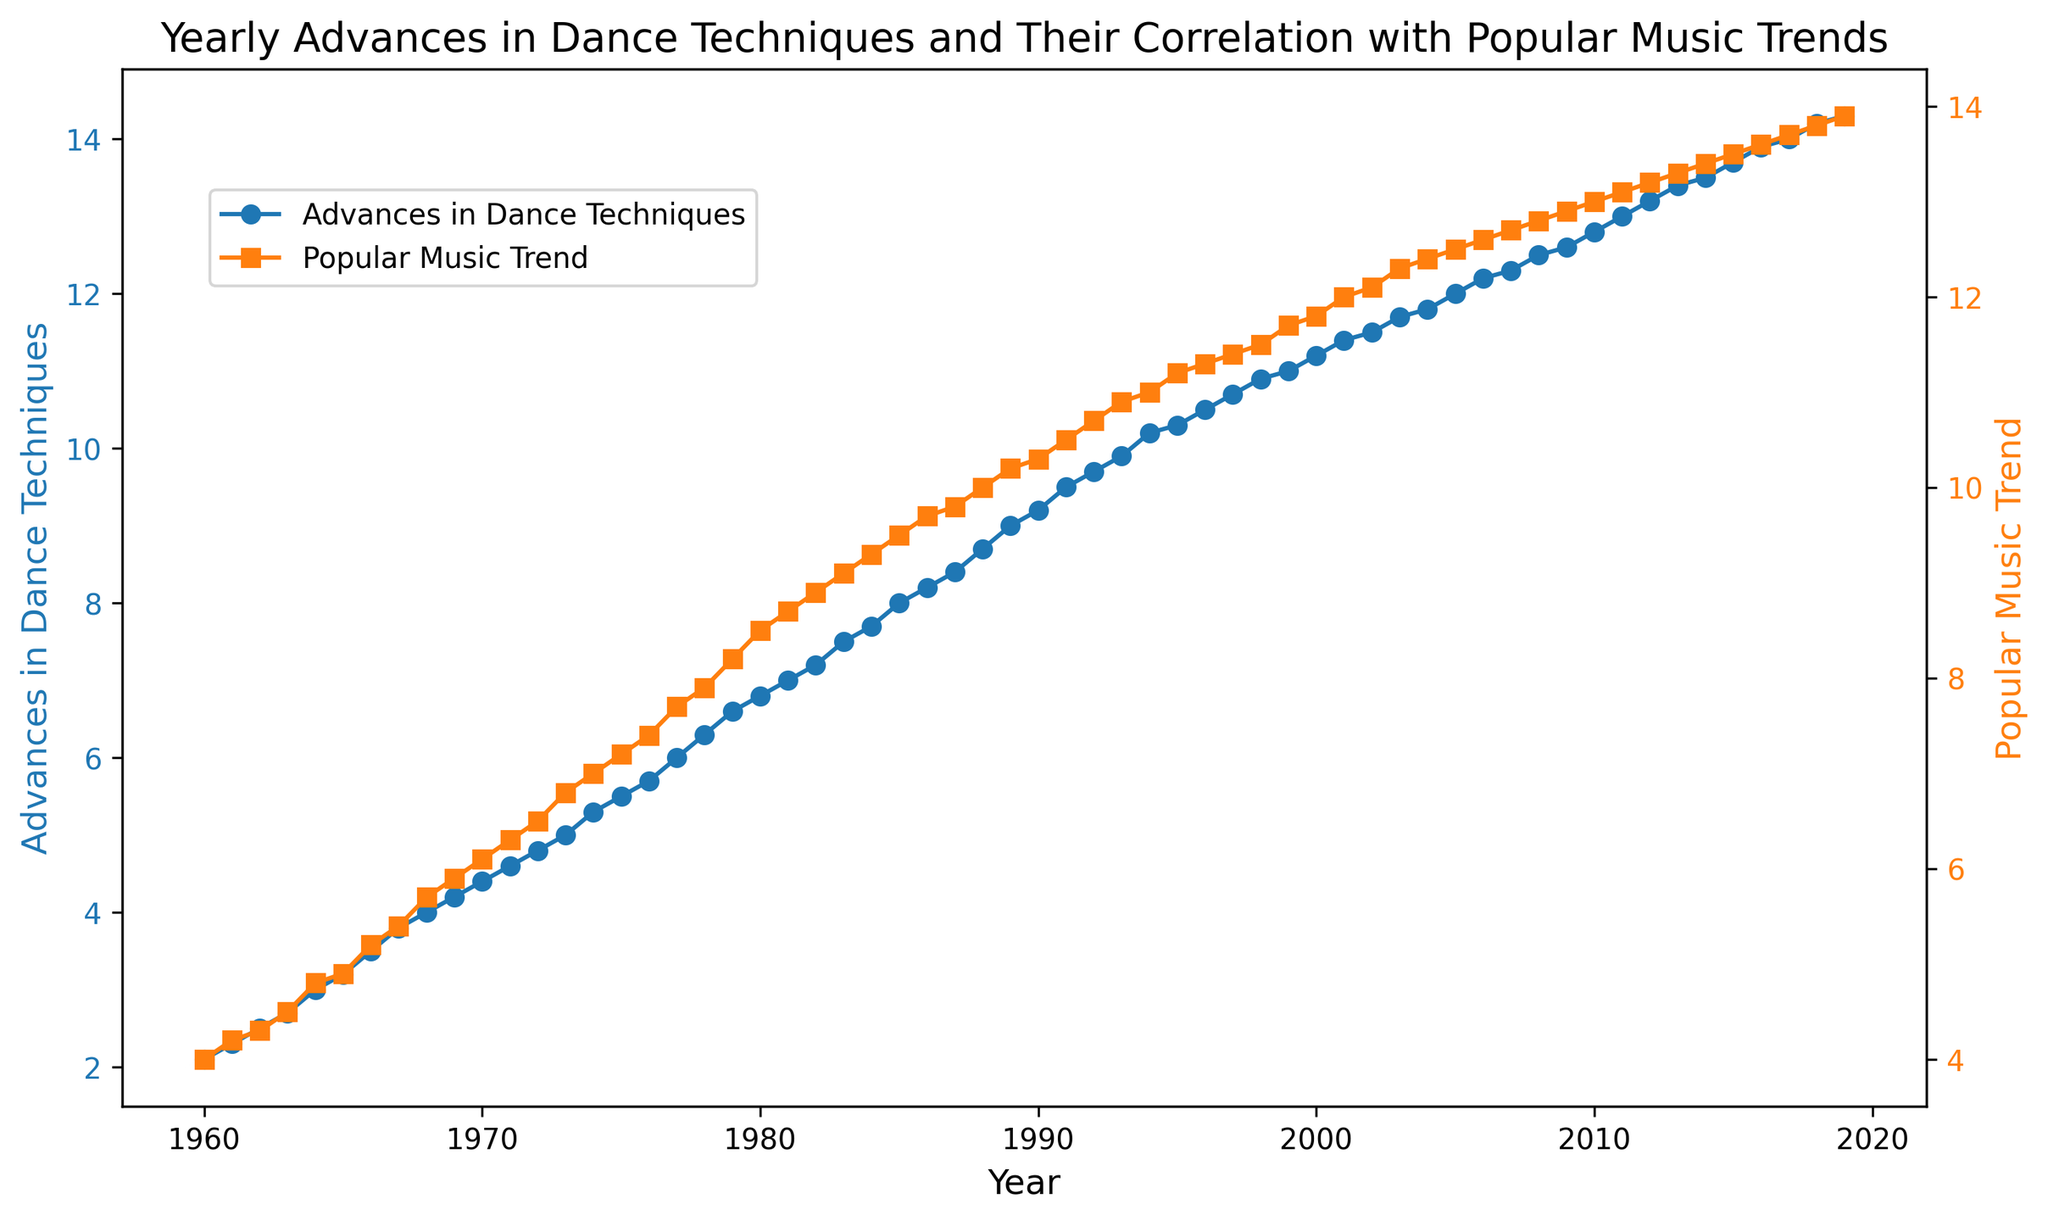Which year shows the highest value in the Popular Music Trend? To find the highest value, look at the Popular Music Trend line (in orange) and identify its peak point. The peak occurs in 2019 with a value of 13.9.
Answer: 2019 What is the difference between Advances in Dance Techniques and Popular Music Trend in the year 1970? From the chart, Advances in Dance Techniques value in 1970 is 4.4, and Popular Music Trend value is 6.1. Subtracting 4.4 from 6.1 gives 1.7.
Answer: 1.7 How many years did it take for Advances in Dance Techniques to double from 1960? Advances in Dance Techniques started at 2.1 in 1960. Doubling that would mean reaching 4.2. Checking the line chart, this value is reached in 1969. Thus, it took 9 years.
Answer: 9 years In which year did the Popular Music Trend first surpass the value of 10? To find the crossing point, follow the orange line and note when it first goes above 10. This happens in 1988.
Answer: 1988 By how much did Advances in Dance Techniques grow from 1990 to 2000? In 1990, Advances in Dance Techniques was 9.2, and in 2000, it was 11.2. The growth is 11.2 - 9.2 = 2.0.
Answer: 2.0 Between 1975 and 1985, which year had the largest gap between Advances in Dance Techniques and Popular Music Trend? Analyze the difference between the two lines for each year in the range. In 1985, Advances in Dance Techniques is at 8.0, and Popular Music Trend is 9.5, making the gap 1.5, which is the largest in this range.
Answer: 1985 What is the average value of Advances in Dance Techniques from 1965 to 1970? The values from 1965 to 1970 are 3.2, 3.5, 3.8, 4.0, 4.2, 4.4. Adding them gives 23.1, and there are 6 values. So, the average is 23.1 / 6 = 3.85.
Answer: 3.85 Do both Advances in Dance Techniques and Popular Music Trend show a general upward trend over the years? Inspect the overall direction of both lines; both show an increase from left to right, signifying a positive trend over the years.
Answer: Yes Which line is steeper between 2010 and 2015? Compare the slopes of the lines between these years. Advances in Dance Techniques grows from 12.8 to 13.7, while Popular Music Trend grows from 13.0 to 13.5 in the same period. The slope for Advances in Dance Techniques is steeper as 13.7 - 12.8 = 0.9, and for Popular Music Trend it's 13.5 - 13.0 = 0.5.
Answer: Advances in Dance Techniques 